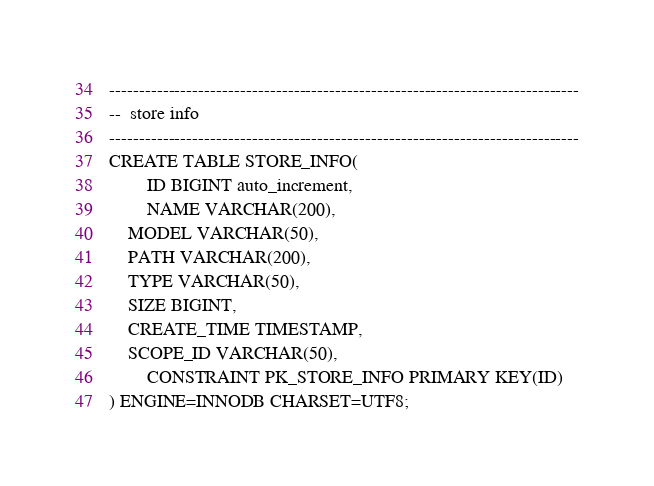<code> <loc_0><loc_0><loc_500><loc_500><_SQL_>

-------------------------------------------------------------------------------
--  store info
-------------------------------------------------------------------------------
CREATE TABLE STORE_INFO(
        ID BIGINT auto_increment,
        NAME VARCHAR(200),
	MODEL VARCHAR(50),
	PATH VARCHAR(200),
	TYPE VARCHAR(50),
	SIZE BIGINT,
	CREATE_TIME TIMESTAMP,
	SCOPE_ID VARCHAR(50),
        CONSTRAINT PK_STORE_INFO PRIMARY KEY(ID)
) ENGINE=INNODB CHARSET=UTF8;
</code> 